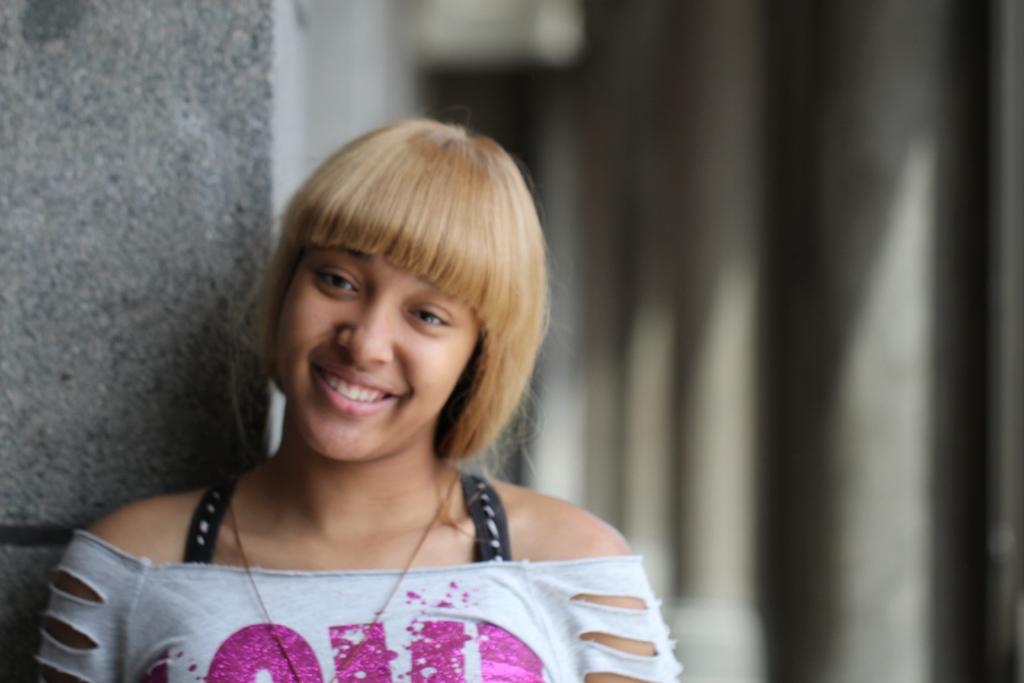Could you give a brief overview of what you see in this image? This picture seems to be clicked inside. In the foreground there is a person wearing white color dress, smiling and seems to be standing. In the background we can see the wall and the background of the image is blurry. 